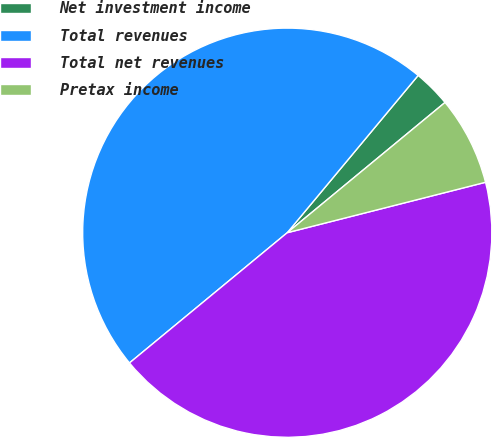Convert chart. <chart><loc_0><loc_0><loc_500><loc_500><pie_chart><fcel>Net investment income<fcel>Total revenues<fcel>Total net revenues<fcel>Pretax income<nl><fcel>2.97%<fcel>47.03%<fcel>42.98%<fcel>7.02%<nl></chart> 